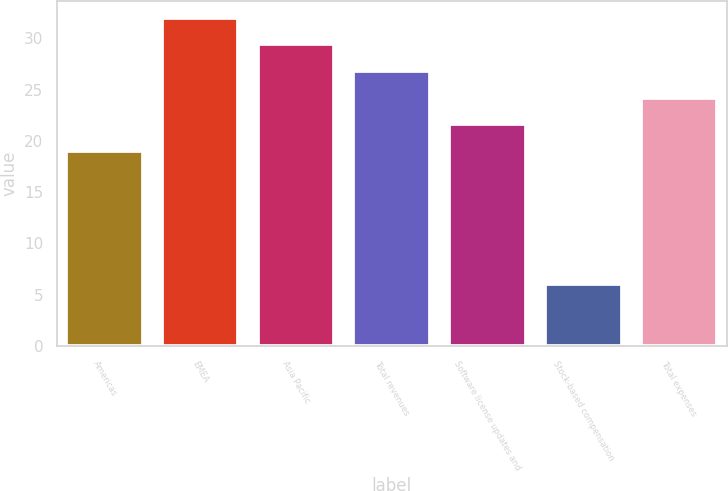<chart> <loc_0><loc_0><loc_500><loc_500><bar_chart><fcel>Americas<fcel>EMEA<fcel>Asia Pacific<fcel>Total revenues<fcel>Software license updates and<fcel>Stock-based compensation<fcel>Total expenses<nl><fcel>19<fcel>32<fcel>29.4<fcel>26.8<fcel>21.6<fcel>6<fcel>24.2<nl></chart> 